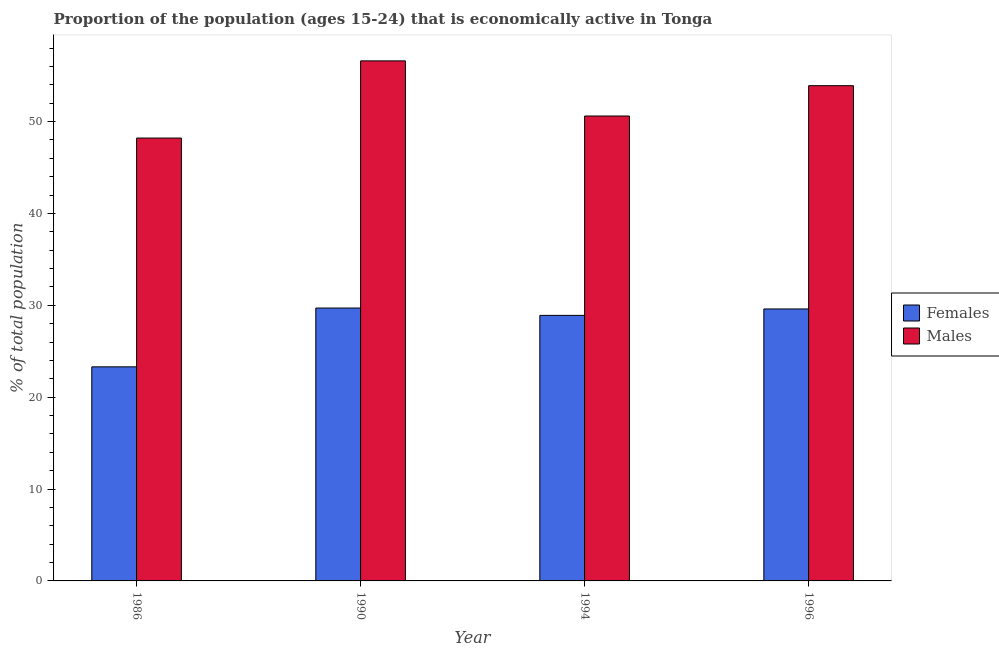How many different coloured bars are there?
Give a very brief answer. 2. How many groups of bars are there?
Offer a very short reply. 4. How many bars are there on the 2nd tick from the left?
Provide a succinct answer. 2. What is the label of the 1st group of bars from the left?
Keep it short and to the point. 1986. In how many cases, is the number of bars for a given year not equal to the number of legend labels?
Your response must be concise. 0. What is the percentage of economically active female population in 1990?
Your answer should be compact. 29.7. Across all years, what is the maximum percentage of economically active female population?
Your answer should be compact. 29.7. Across all years, what is the minimum percentage of economically active female population?
Your response must be concise. 23.3. In which year was the percentage of economically active female population minimum?
Ensure brevity in your answer.  1986. What is the total percentage of economically active male population in the graph?
Make the answer very short. 209.3. What is the difference between the percentage of economically active male population in 1986 and that in 1994?
Provide a short and direct response. -2.4. What is the difference between the percentage of economically active male population in 1990 and the percentage of economically active female population in 1996?
Your answer should be very brief. 2.7. What is the average percentage of economically active male population per year?
Provide a short and direct response. 52.32. In the year 1996, what is the difference between the percentage of economically active female population and percentage of economically active male population?
Keep it short and to the point. 0. In how many years, is the percentage of economically active male population greater than 38 %?
Your answer should be compact. 4. What is the ratio of the percentage of economically active male population in 1994 to that in 1996?
Your response must be concise. 0.94. Is the difference between the percentage of economically active male population in 1990 and 1994 greater than the difference between the percentage of economically active female population in 1990 and 1994?
Provide a short and direct response. No. What is the difference between the highest and the second highest percentage of economically active female population?
Keep it short and to the point. 0.1. What is the difference between the highest and the lowest percentage of economically active female population?
Provide a succinct answer. 6.4. In how many years, is the percentage of economically active male population greater than the average percentage of economically active male population taken over all years?
Keep it short and to the point. 2. What does the 2nd bar from the left in 1986 represents?
Keep it short and to the point. Males. What does the 2nd bar from the right in 1986 represents?
Offer a terse response. Females. How many bars are there?
Your answer should be very brief. 8. What is the difference between two consecutive major ticks on the Y-axis?
Keep it short and to the point. 10. Does the graph contain grids?
Provide a succinct answer. No. Where does the legend appear in the graph?
Provide a short and direct response. Center right. How are the legend labels stacked?
Your answer should be very brief. Vertical. What is the title of the graph?
Your response must be concise. Proportion of the population (ages 15-24) that is economically active in Tonga. Does "Death rate" appear as one of the legend labels in the graph?
Keep it short and to the point. No. What is the label or title of the X-axis?
Your answer should be compact. Year. What is the label or title of the Y-axis?
Your response must be concise. % of total population. What is the % of total population of Females in 1986?
Provide a succinct answer. 23.3. What is the % of total population of Males in 1986?
Offer a very short reply. 48.2. What is the % of total population of Females in 1990?
Ensure brevity in your answer.  29.7. What is the % of total population of Males in 1990?
Give a very brief answer. 56.6. What is the % of total population in Females in 1994?
Your response must be concise. 28.9. What is the % of total population in Males in 1994?
Provide a short and direct response. 50.6. What is the % of total population of Females in 1996?
Your response must be concise. 29.6. What is the % of total population in Males in 1996?
Offer a terse response. 53.9. Across all years, what is the maximum % of total population of Females?
Keep it short and to the point. 29.7. Across all years, what is the maximum % of total population in Males?
Make the answer very short. 56.6. Across all years, what is the minimum % of total population of Females?
Provide a short and direct response. 23.3. Across all years, what is the minimum % of total population in Males?
Your response must be concise. 48.2. What is the total % of total population in Females in the graph?
Make the answer very short. 111.5. What is the total % of total population of Males in the graph?
Provide a short and direct response. 209.3. What is the difference between the % of total population in Males in 1986 and that in 1990?
Keep it short and to the point. -8.4. What is the difference between the % of total population of Females in 1986 and that in 1994?
Offer a terse response. -5.6. What is the difference between the % of total population of Females in 1986 and that in 1996?
Your answer should be very brief. -6.3. What is the difference between the % of total population of Males in 1986 and that in 1996?
Your response must be concise. -5.7. What is the difference between the % of total population of Males in 1990 and that in 1994?
Offer a very short reply. 6. What is the difference between the % of total population of Males in 1990 and that in 1996?
Keep it short and to the point. 2.7. What is the difference between the % of total population in Females in 1994 and that in 1996?
Provide a short and direct response. -0.7. What is the difference between the % of total population of Females in 1986 and the % of total population of Males in 1990?
Offer a terse response. -33.3. What is the difference between the % of total population in Females in 1986 and the % of total population in Males in 1994?
Ensure brevity in your answer.  -27.3. What is the difference between the % of total population of Females in 1986 and the % of total population of Males in 1996?
Offer a terse response. -30.6. What is the difference between the % of total population of Females in 1990 and the % of total population of Males in 1994?
Your answer should be compact. -20.9. What is the difference between the % of total population in Females in 1990 and the % of total population in Males in 1996?
Your answer should be compact. -24.2. What is the difference between the % of total population of Females in 1994 and the % of total population of Males in 1996?
Provide a succinct answer. -25. What is the average % of total population in Females per year?
Give a very brief answer. 27.88. What is the average % of total population of Males per year?
Your response must be concise. 52.33. In the year 1986, what is the difference between the % of total population in Females and % of total population in Males?
Keep it short and to the point. -24.9. In the year 1990, what is the difference between the % of total population of Females and % of total population of Males?
Your answer should be compact. -26.9. In the year 1994, what is the difference between the % of total population of Females and % of total population of Males?
Make the answer very short. -21.7. In the year 1996, what is the difference between the % of total population of Females and % of total population of Males?
Provide a succinct answer. -24.3. What is the ratio of the % of total population of Females in 1986 to that in 1990?
Keep it short and to the point. 0.78. What is the ratio of the % of total population in Males in 1986 to that in 1990?
Provide a succinct answer. 0.85. What is the ratio of the % of total population in Females in 1986 to that in 1994?
Your response must be concise. 0.81. What is the ratio of the % of total population in Males in 1986 to that in 1994?
Ensure brevity in your answer.  0.95. What is the ratio of the % of total population in Females in 1986 to that in 1996?
Keep it short and to the point. 0.79. What is the ratio of the % of total population of Males in 1986 to that in 1996?
Provide a short and direct response. 0.89. What is the ratio of the % of total population in Females in 1990 to that in 1994?
Give a very brief answer. 1.03. What is the ratio of the % of total population in Males in 1990 to that in 1994?
Offer a terse response. 1.12. What is the ratio of the % of total population in Females in 1990 to that in 1996?
Your answer should be compact. 1. What is the ratio of the % of total population of Males in 1990 to that in 1996?
Offer a terse response. 1.05. What is the ratio of the % of total population of Females in 1994 to that in 1996?
Make the answer very short. 0.98. What is the ratio of the % of total population of Males in 1994 to that in 1996?
Keep it short and to the point. 0.94. What is the difference between the highest and the second highest % of total population in Males?
Give a very brief answer. 2.7. What is the difference between the highest and the lowest % of total population of Females?
Your response must be concise. 6.4. 